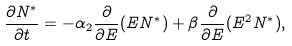<formula> <loc_0><loc_0><loc_500><loc_500>\frac { \partial N ^ { * } } { \partial t } = - \alpha _ { 2 } \frac { \partial } { \partial E } ( E N ^ { * } ) + \beta \frac { \partial } { \partial E } ( E ^ { 2 } N ^ { * } ) ,</formula> 